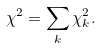Convert formula to latex. <formula><loc_0><loc_0><loc_500><loc_500>\chi ^ { 2 } = \sum _ { k } { \chi ^ { 2 } _ { k } } .</formula> 